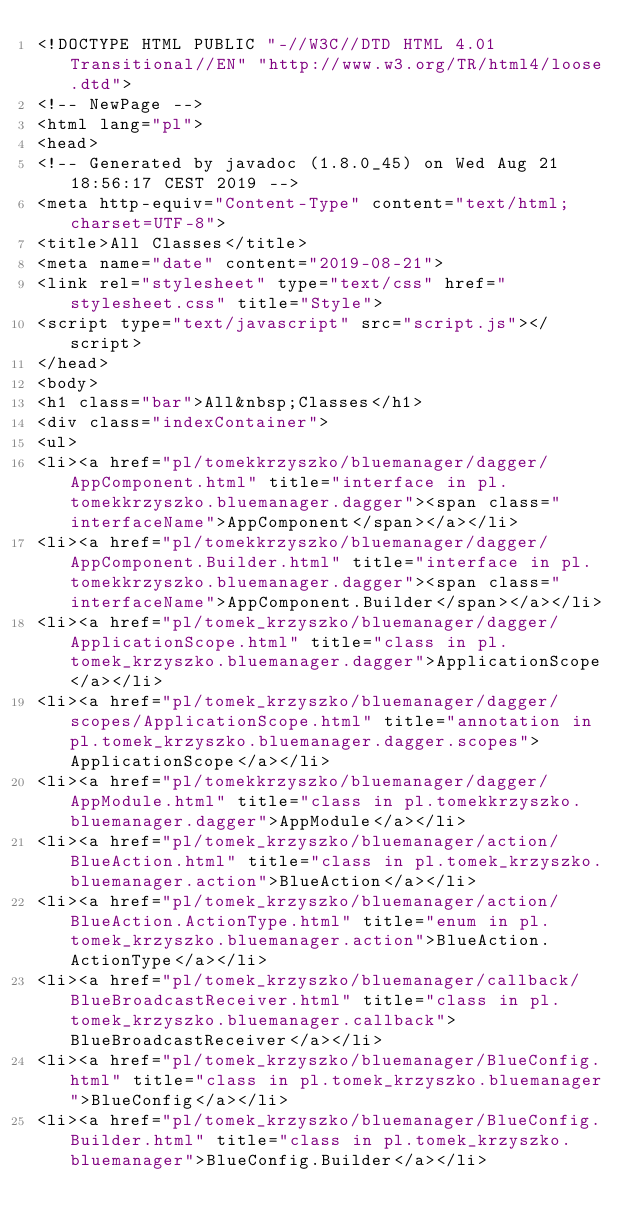<code> <loc_0><loc_0><loc_500><loc_500><_HTML_><!DOCTYPE HTML PUBLIC "-//W3C//DTD HTML 4.01 Transitional//EN" "http://www.w3.org/TR/html4/loose.dtd">
<!-- NewPage -->
<html lang="pl">
<head>
<!-- Generated by javadoc (1.8.0_45) on Wed Aug 21 18:56:17 CEST 2019 -->
<meta http-equiv="Content-Type" content="text/html; charset=UTF-8">
<title>All Classes</title>
<meta name="date" content="2019-08-21">
<link rel="stylesheet" type="text/css" href="stylesheet.css" title="Style">
<script type="text/javascript" src="script.js"></script>
</head>
<body>
<h1 class="bar">All&nbsp;Classes</h1>
<div class="indexContainer">
<ul>
<li><a href="pl/tomekkrzyszko/bluemanager/dagger/AppComponent.html" title="interface in pl.tomekkrzyszko.bluemanager.dagger"><span class="interfaceName">AppComponent</span></a></li>
<li><a href="pl/tomekkrzyszko/bluemanager/dagger/AppComponent.Builder.html" title="interface in pl.tomekkrzyszko.bluemanager.dagger"><span class="interfaceName">AppComponent.Builder</span></a></li>
<li><a href="pl/tomek_krzyszko/bluemanager/dagger/ApplicationScope.html" title="class in pl.tomek_krzyszko.bluemanager.dagger">ApplicationScope</a></li>
<li><a href="pl/tomek_krzyszko/bluemanager/dagger/scopes/ApplicationScope.html" title="annotation in pl.tomek_krzyszko.bluemanager.dagger.scopes">ApplicationScope</a></li>
<li><a href="pl/tomekkrzyszko/bluemanager/dagger/AppModule.html" title="class in pl.tomekkrzyszko.bluemanager.dagger">AppModule</a></li>
<li><a href="pl/tomek_krzyszko/bluemanager/action/BlueAction.html" title="class in pl.tomek_krzyszko.bluemanager.action">BlueAction</a></li>
<li><a href="pl/tomek_krzyszko/bluemanager/action/BlueAction.ActionType.html" title="enum in pl.tomek_krzyszko.bluemanager.action">BlueAction.ActionType</a></li>
<li><a href="pl/tomek_krzyszko/bluemanager/callback/BlueBroadcastReceiver.html" title="class in pl.tomek_krzyszko.bluemanager.callback">BlueBroadcastReceiver</a></li>
<li><a href="pl/tomek_krzyszko/bluemanager/BlueConfig.html" title="class in pl.tomek_krzyszko.bluemanager">BlueConfig</a></li>
<li><a href="pl/tomek_krzyszko/bluemanager/BlueConfig.Builder.html" title="class in pl.tomek_krzyszko.bluemanager">BlueConfig.Builder</a></li></code> 